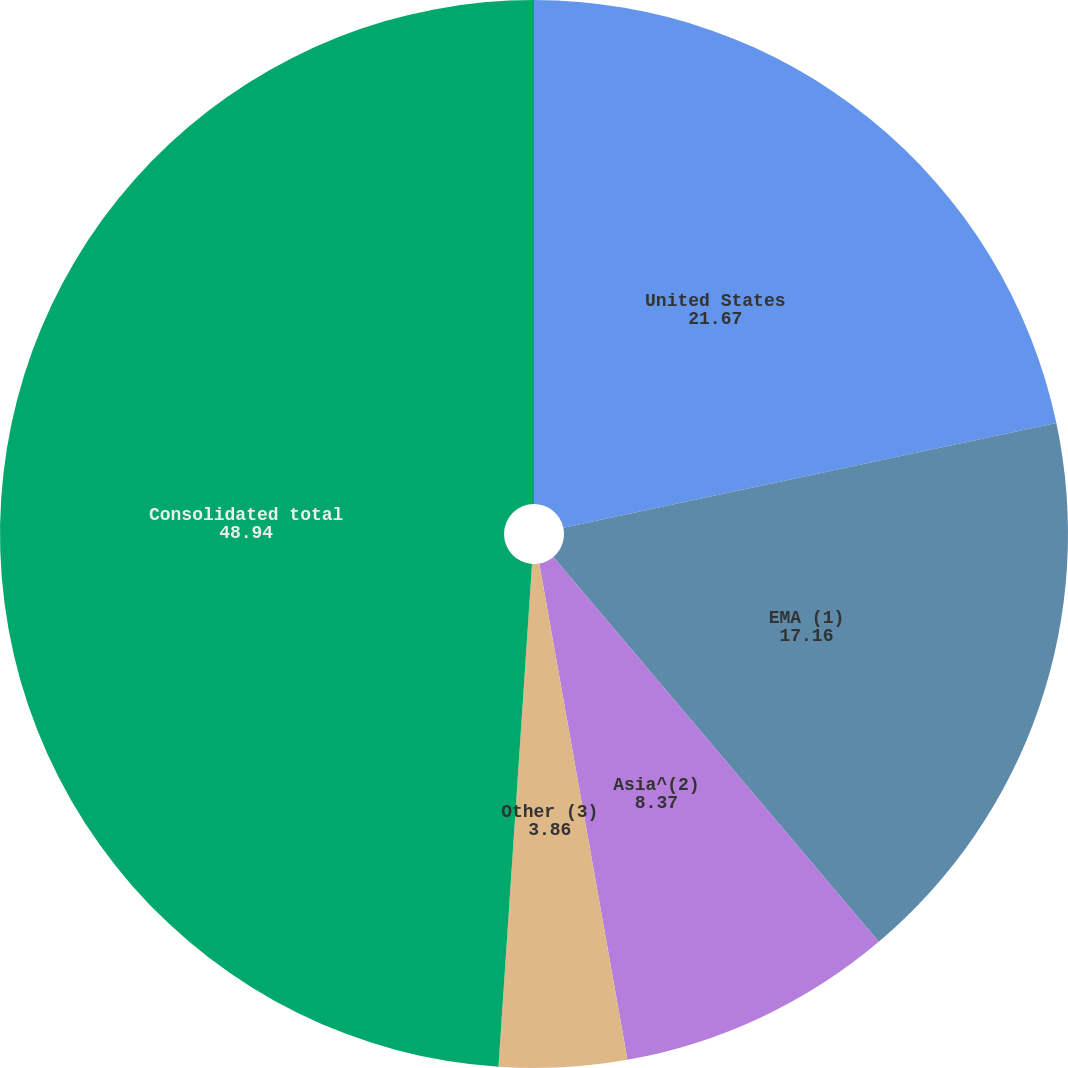<chart> <loc_0><loc_0><loc_500><loc_500><pie_chart><fcel>United States<fcel>EMA (1)<fcel>Asia^(2)<fcel>Other (3)<fcel>Consolidated total<nl><fcel>21.67%<fcel>17.16%<fcel>8.37%<fcel>3.86%<fcel>48.94%<nl></chart> 